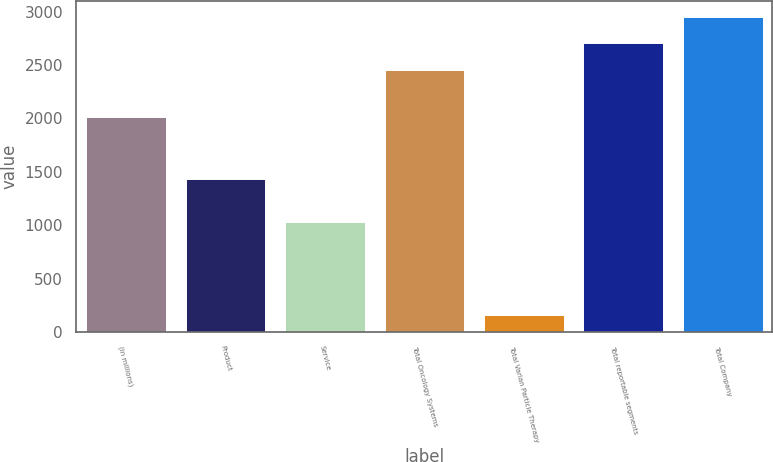Convert chart to OTSL. <chart><loc_0><loc_0><loc_500><loc_500><bar_chart><fcel>(In millions)<fcel>Product<fcel>Service<fcel>Total Oncology Systems<fcel>Total Varian Particle Therapy<fcel>Total reportable segments<fcel>Total Company<nl><fcel>2016<fcel>1430.3<fcel>1027.7<fcel>2458<fcel>162.6<fcel>2703.85<fcel>2949.7<nl></chart> 